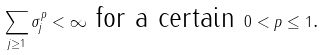<formula> <loc_0><loc_0><loc_500><loc_500>\sum _ { j \geq 1 } \sigma _ { j } ^ { p } < \infty \text { for a certain } 0 < p \leq 1 \text {. }</formula> 